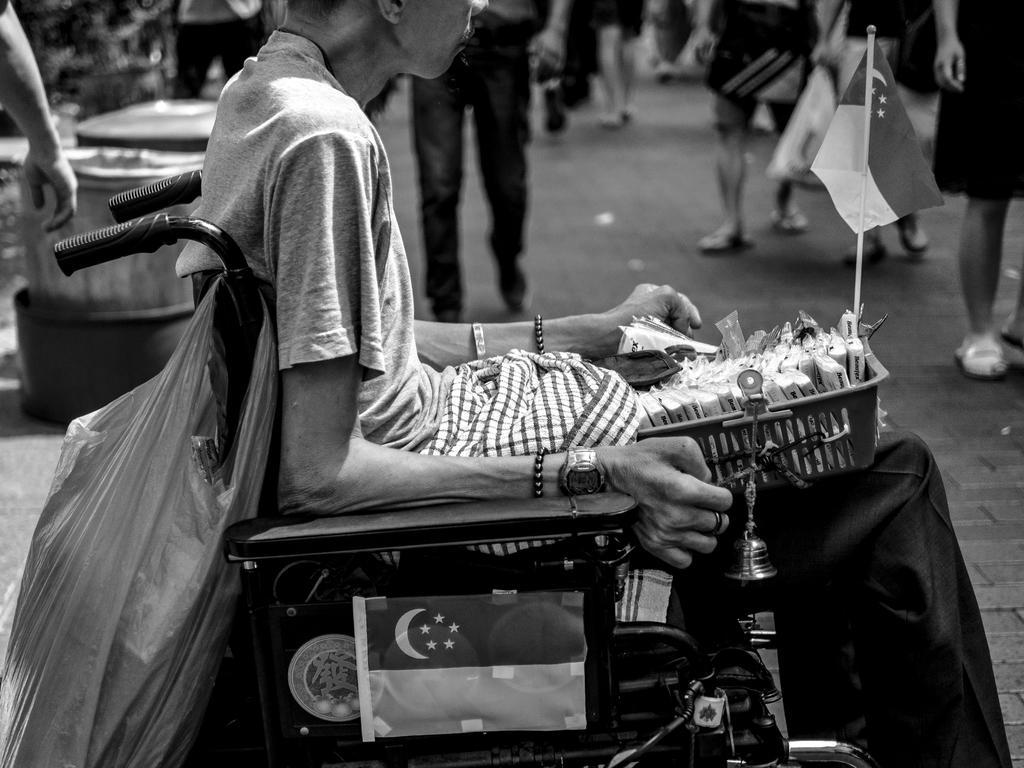Could you give a brief overview of what you see in this image? This picture shows a woman seated on the wheelchair and he is holding a basket and a carry bag hanging and we see a flag to the basket and few people walking. 